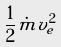Convert formula to latex. <formula><loc_0><loc_0><loc_500><loc_500>\frac { 1 } { 2 } \dot { m } v _ { e } ^ { 2 }</formula> 